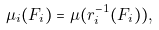Convert formula to latex. <formula><loc_0><loc_0><loc_500><loc_500>\mu _ { i } ( F _ { i } ) = \mu ( r _ { i } ^ { - 1 } ( F _ { i } ) ) ,</formula> 